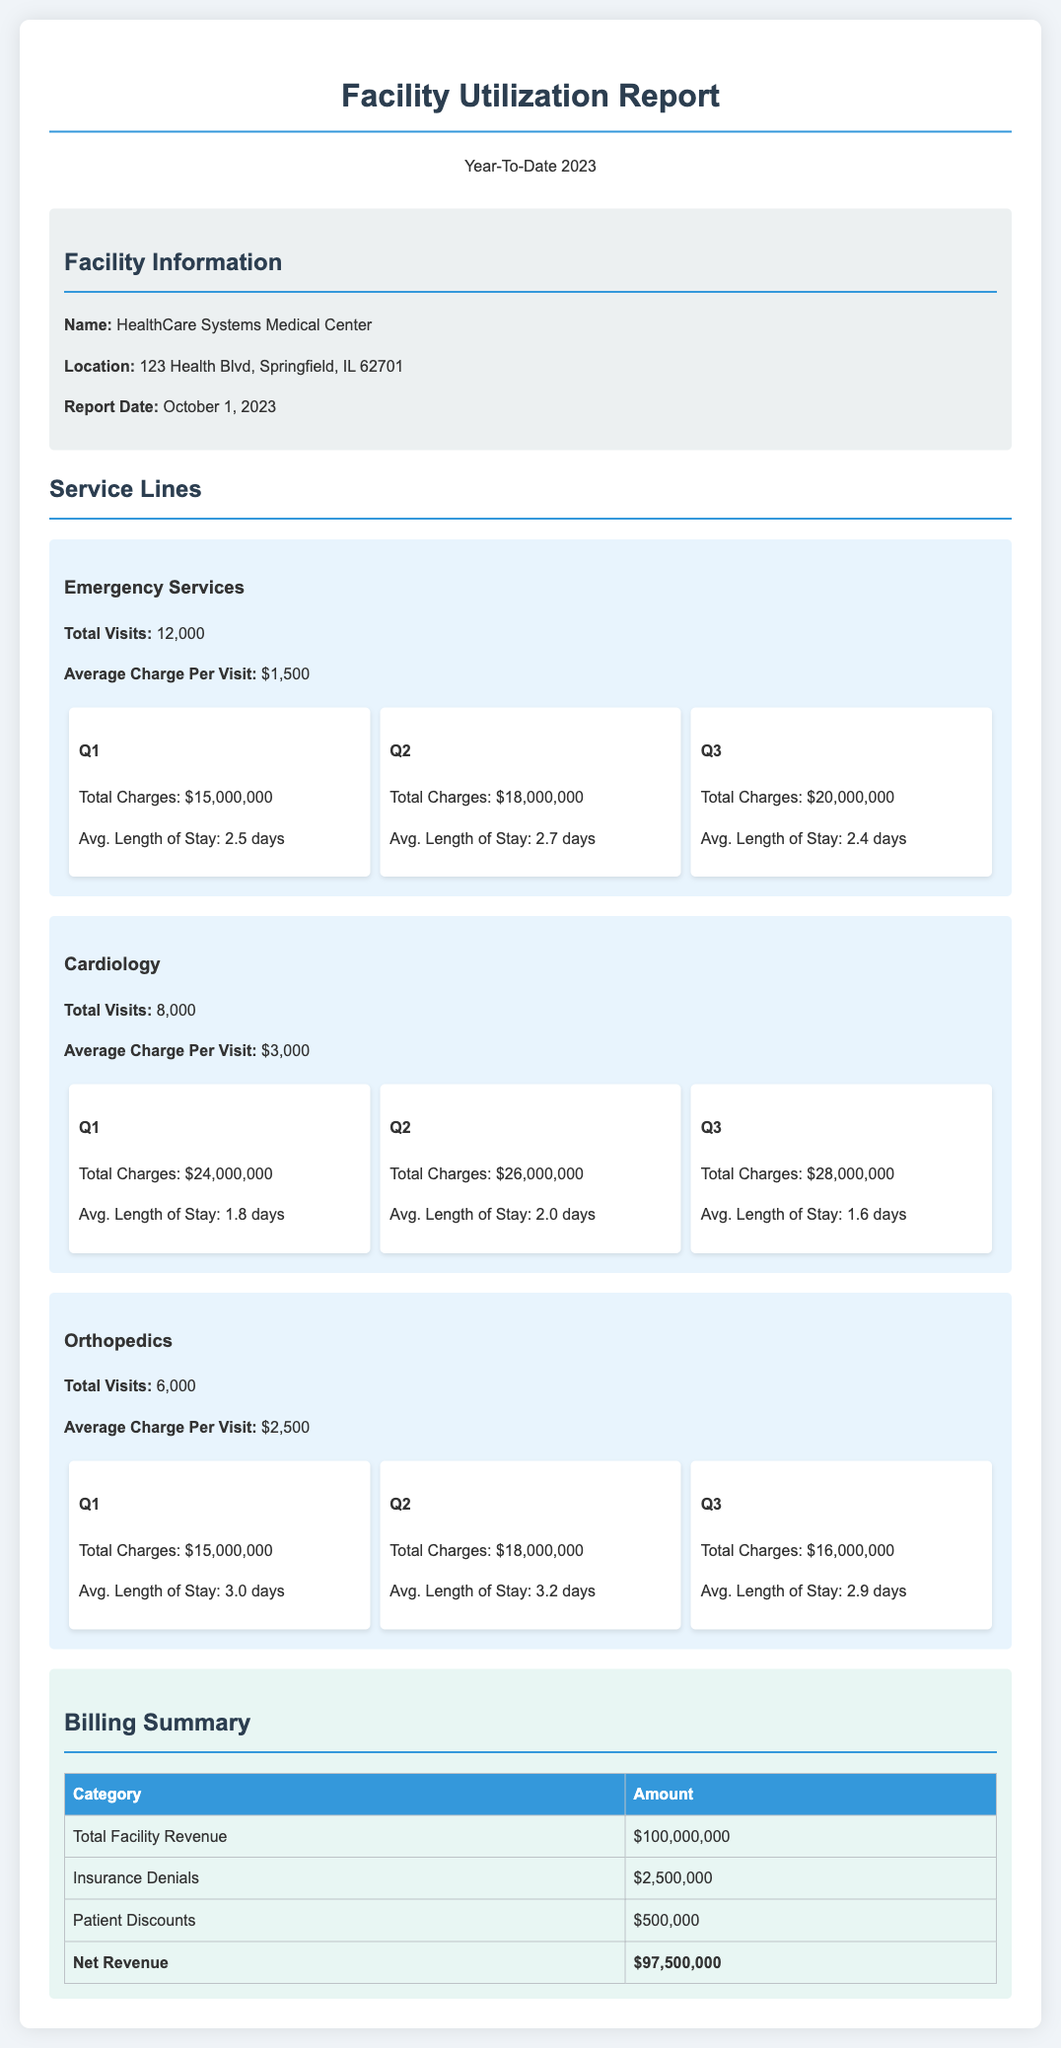what is the total number of Emergency Services visits? The document lists the total visits for Emergency Services as 12,000.
Answer: 12,000 what is the average charge per visit for Cardiology? The average charge per visit for Cardiology is stated as $3,000.
Answer: $3,000 how much was the total facility revenue? The total facility revenue is indicated as $100,000,000 in the billing summary.
Answer: $100,000,000 what was the total charge in Q2 for Orthopedics? The total charge for Orthopedics in Q2 is listed as $18,000,000.
Answer: $18,000,000 how much was lost due to insurance denials? The document specifies that insurance denials amounted to $2,500,000.
Answer: $2,500,000 which service line had the highest total charges in Q3? In Q3, the service line with the highest total charges was Cardiology at $28,000,000.
Answer: Cardiology what was the average length of stay for Emergency Services in Q1? The average length of stay for Emergency Services in Q1 is 2.5 days.
Answer: 2.5 days what is the net revenue after adjustments? The net revenue, after accounting for discounts and denials, is stated as $97,500,000.
Answer: $97,500,000 how many total visits were recorded for Orthopedics? The document shows that there were 6,000 total visits for Orthopedics.
Answer: 6,000 